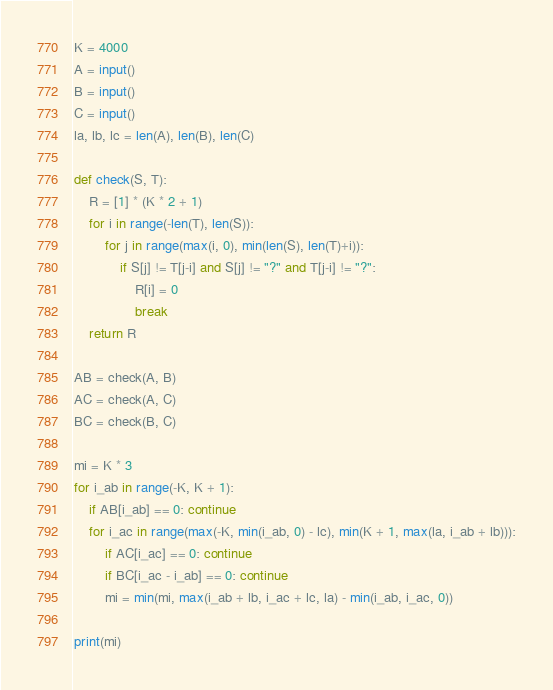<code> <loc_0><loc_0><loc_500><loc_500><_Python_>K = 4000
A = input()
B = input()
C = input()
la, lb, lc = len(A), len(B), len(C)

def check(S, T):
    R = [1] * (K * 2 + 1)
    for i in range(-len(T), len(S)):
        for j in range(max(i, 0), min(len(S), len(T)+i)):
            if S[j] != T[j-i] and S[j] != "?" and T[j-i] != "?":
                R[i] = 0
                break
    return R

AB = check(A, B)
AC = check(A, C)
BC = check(B, C)

mi = K * 3
for i_ab in range(-K, K + 1):
    if AB[i_ab] == 0: continue
    for i_ac in range(max(-K, min(i_ab, 0) - lc), min(K + 1, max(la, i_ab + lb))):
        if AC[i_ac] == 0: continue
        if BC[i_ac - i_ab] == 0: continue
        mi = min(mi, max(i_ab + lb, i_ac + lc, la) - min(i_ab, i_ac, 0))

print(mi)</code> 